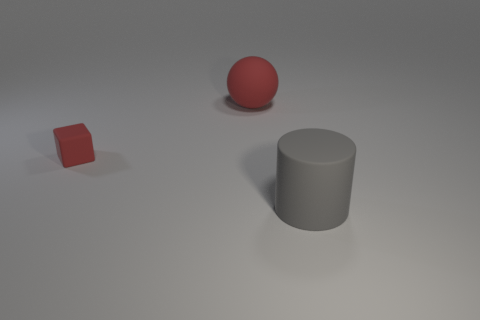What is the color of the big cylinder?
Ensure brevity in your answer.  Gray. Are there any big things to the right of the red rubber ball?
Your answer should be very brief. Yes. There is a tiny red matte thing; is its shape the same as the big rubber thing behind the rubber cylinder?
Ensure brevity in your answer.  No. How many other things are made of the same material as the red block?
Offer a terse response. 2. What color is the tiny rubber thing that is in front of the big thing that is on the left side of the rubber thing on the right side of the red sphere?
Provide a succinct answer. Red. What is the shape of the matte object that is on the right side of the big thing that is left of the large gray rubber cylinder?
Your answer should be compact. Cylinder. Is the number of balls on the left side of the red matte sphere greater than the number of tiny red matte things?
Offer a very short reply. No. There is a thing to the right of the red matte sphere; is its shape the same as the large red thing?
Give a very brief answer. No. Is there a big blue metal object that has the same shape as the small red rubber thing?
Ensure brevity in your answer.  No. How many objects are either things that are on the left side of the gray cylinder or large gray cylinders?
Your response must be concise. 3. 